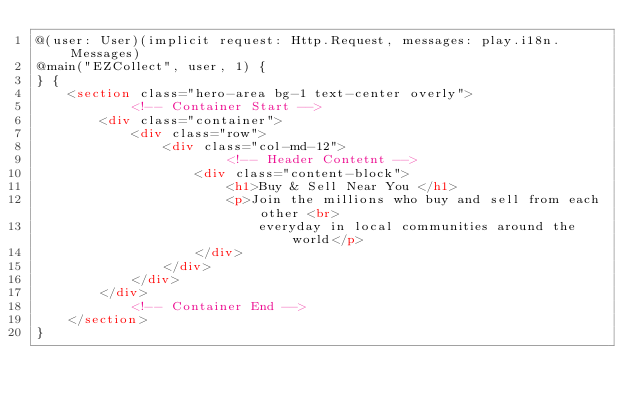Convert code to text. <code><loc_0><loc_0><loc_500><loc_500><_HTML_>@(user: User)(implicit request: Http.Request, messages: play.i18n.Messages)
@main("EZCollect", user, 1) {
} {
    <section class="hero-area bg-1 text-center overly">
            <!-- Container Start -->
        <div class="container">
            <div class="row">
                <div class="col-md-12">
                        <!-- Header Contetnt -->
                    <div class="content-block">
                        <h1>Buy & Sell Near You </h1>
                        <p>Join the millions who buy and sell from each other <br>
                            everyday in local communities around the world</p>
                    </div>
                </div>
            </div>
        </div>
            <!-- Container End -->
    </section>
}
</code> 